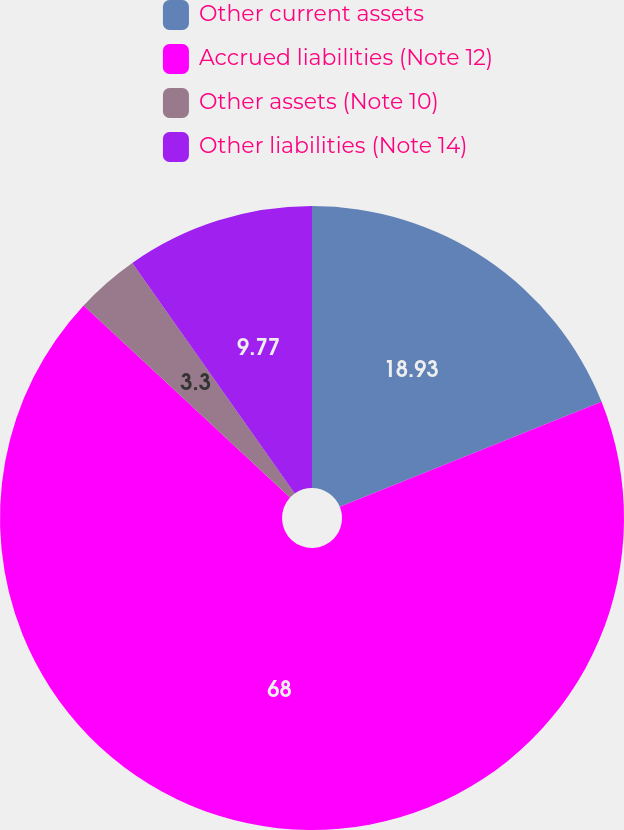Convert chart to OTSL. <chart><loc_0><loc_0><loc_500><loc_500><pie_chart><fcel>Other current assets<fcel>Accrued liabilities (Note 12)<fcel>Other assets (Note 10)<fcel>Other liabilities (Note 14)<nl><fcel>18.93%<fcel>68.01%<fcel>3.3%<fcel>9.77%<nl></chart> 